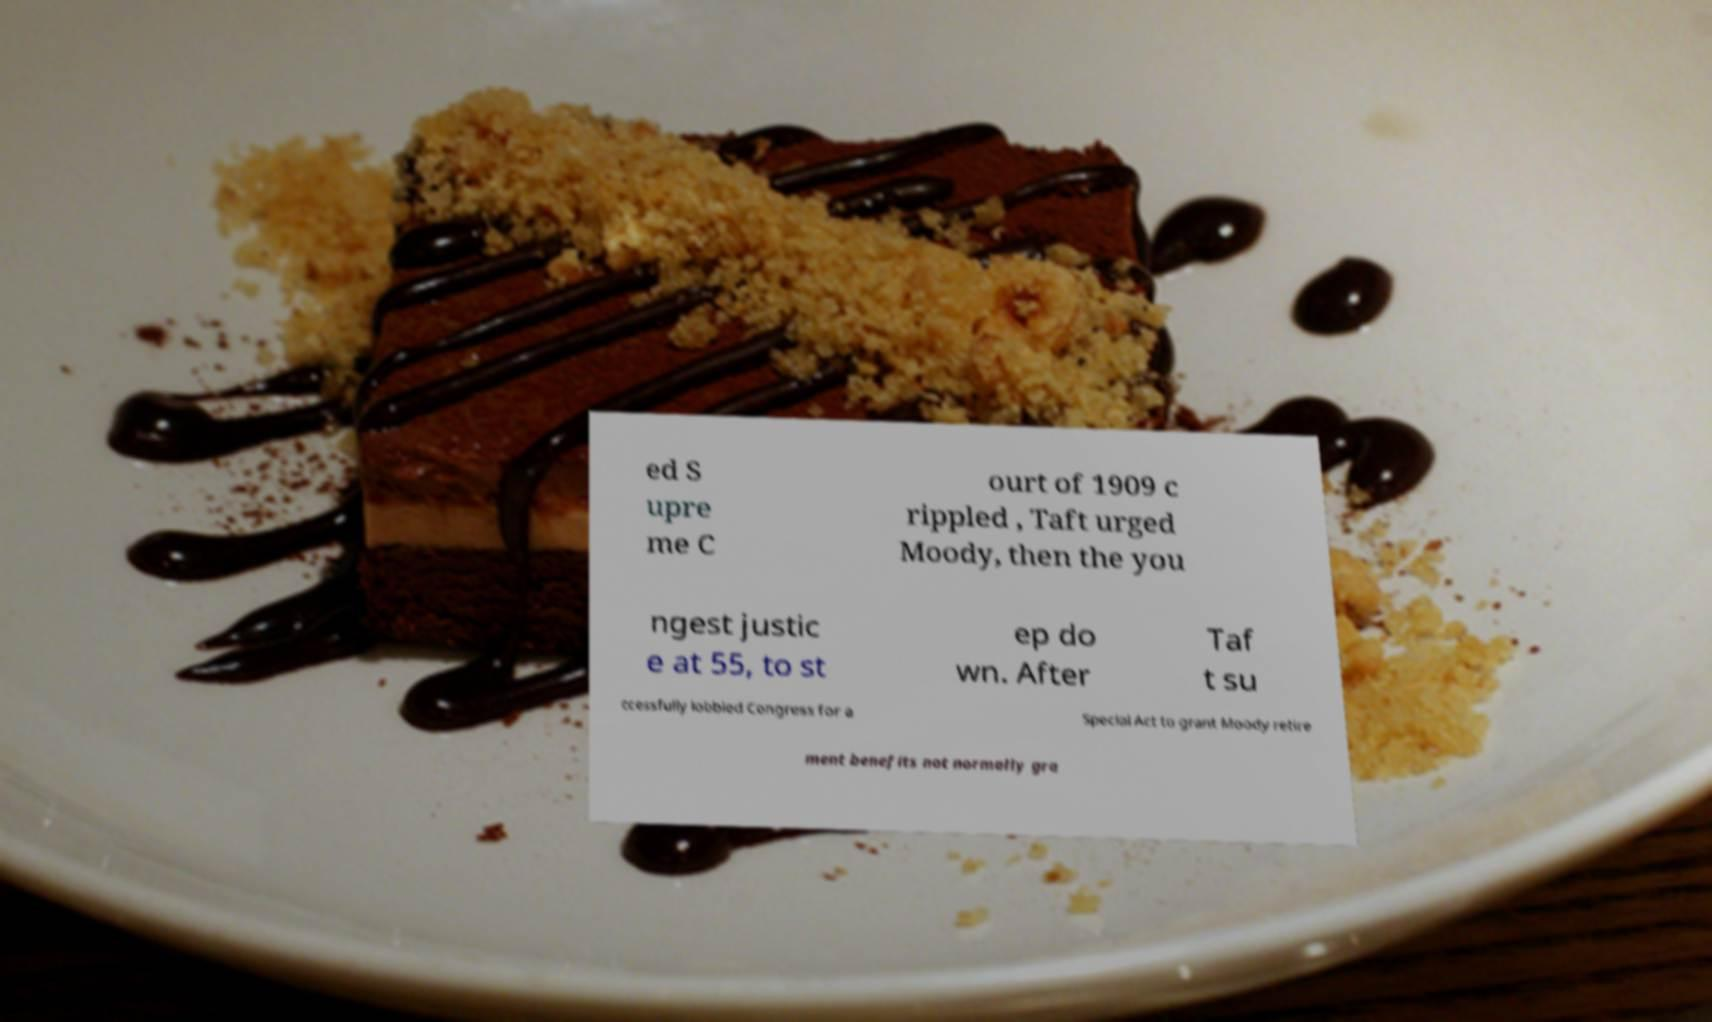For documentation purposes, I need the text within this image transcribed. Could you provide that? ed S upre me C ourt of 1909 c rippled , Taft urged Moody, then the you ngest justic e at 55, to st ep do wn. After Taf t su ccessfully lobbied Congress for a Special Act to grant Moody retire ment benefits not normally gra 